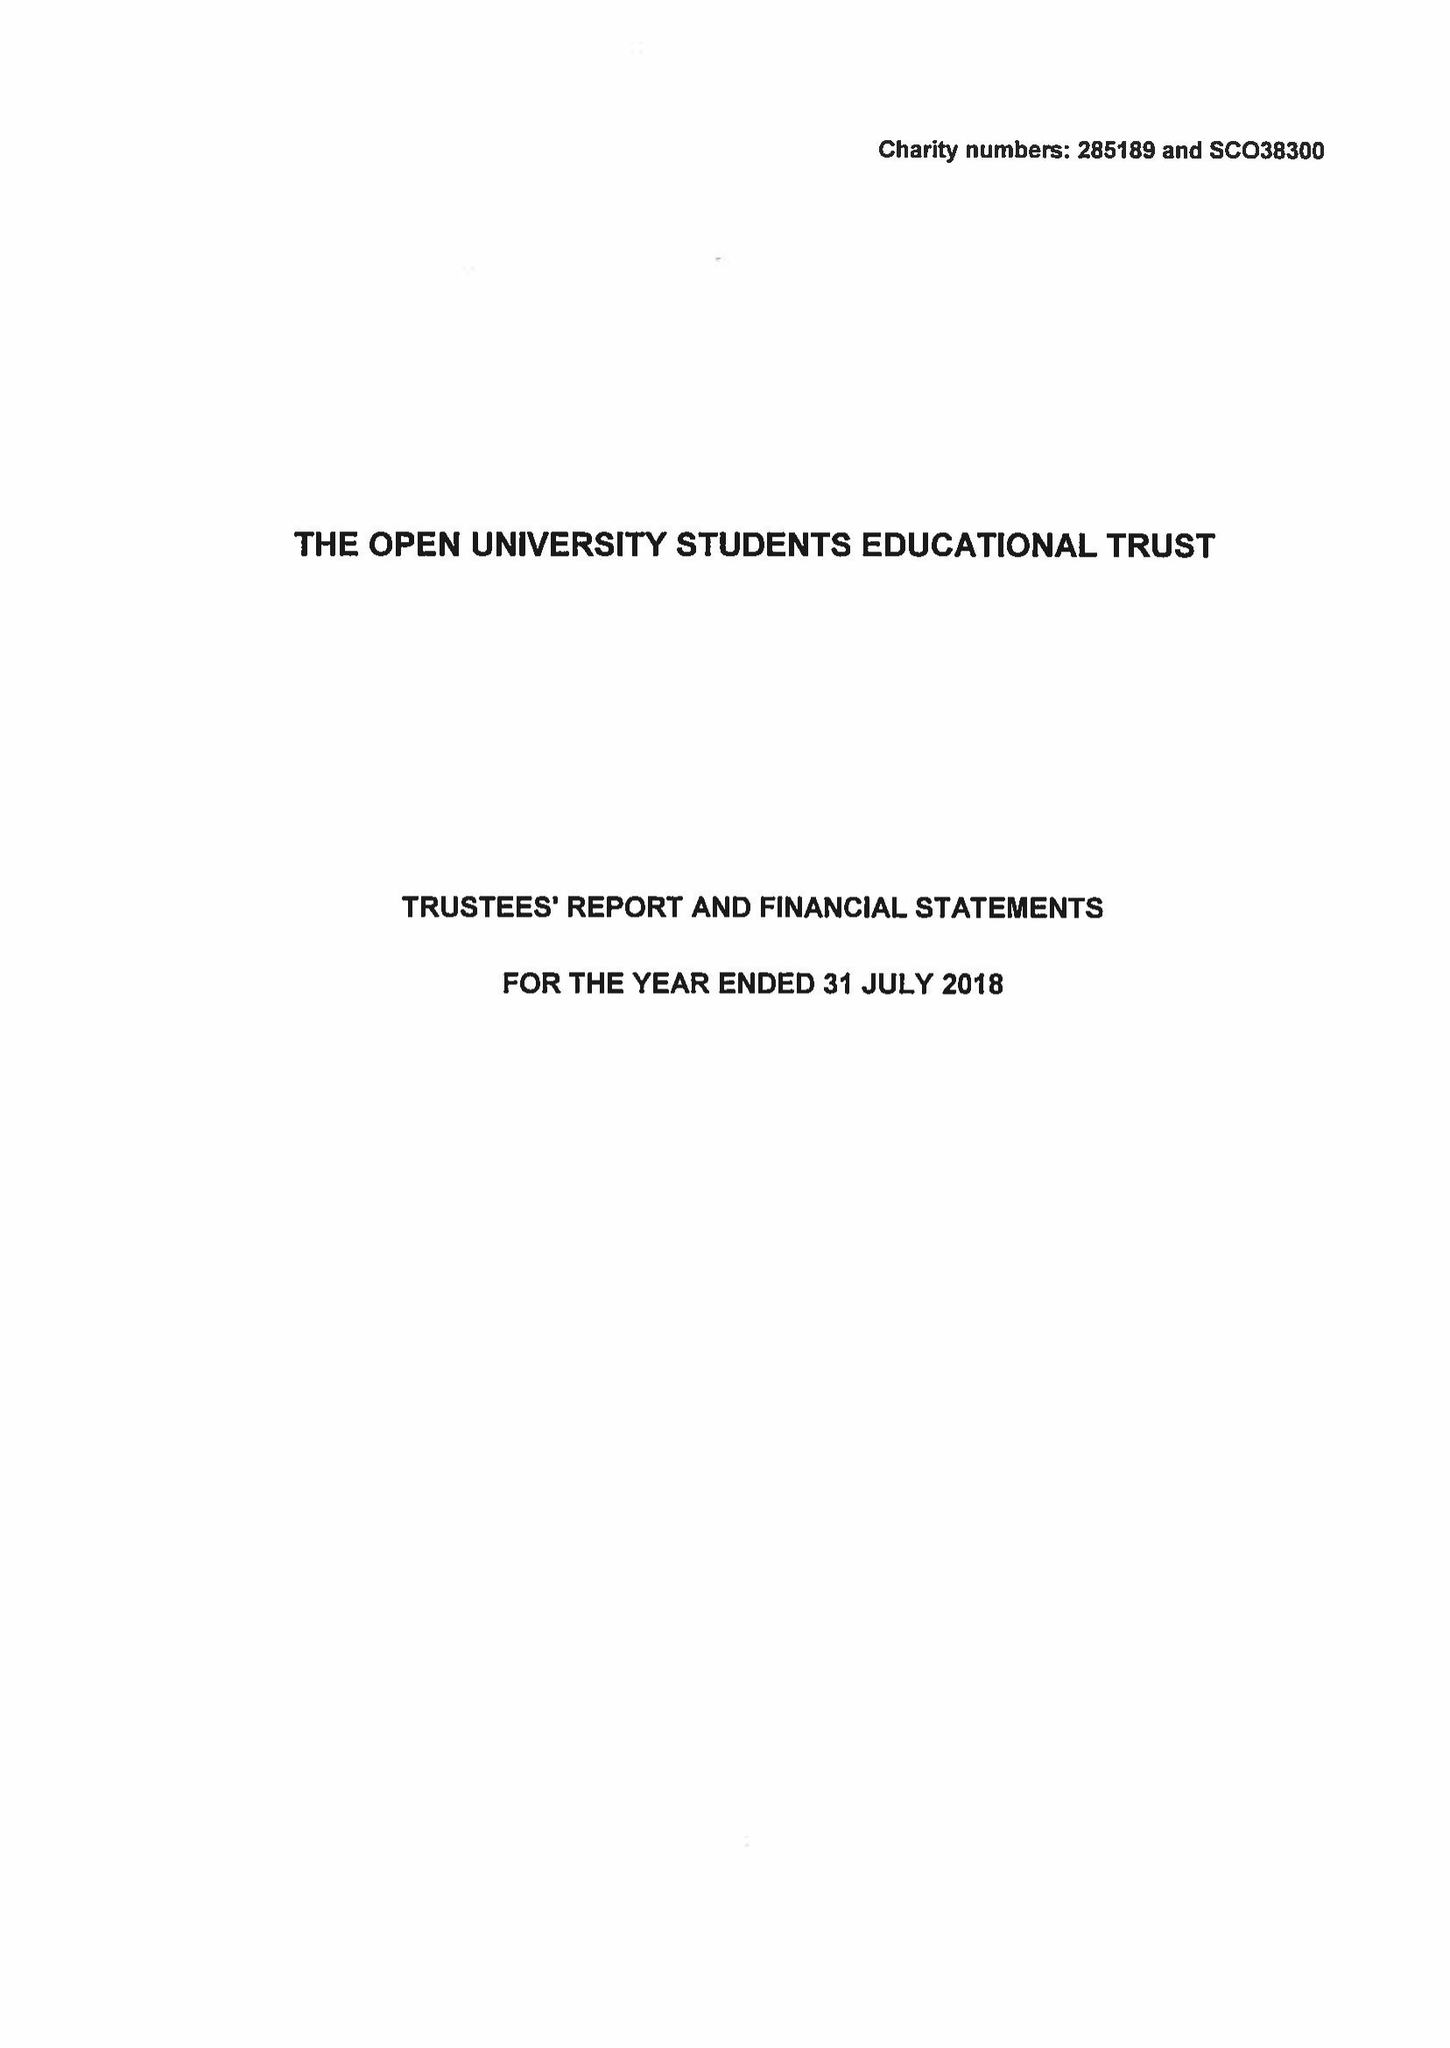What is the value for the charity_number?
Answer the question using a single word or phrase. 285189 